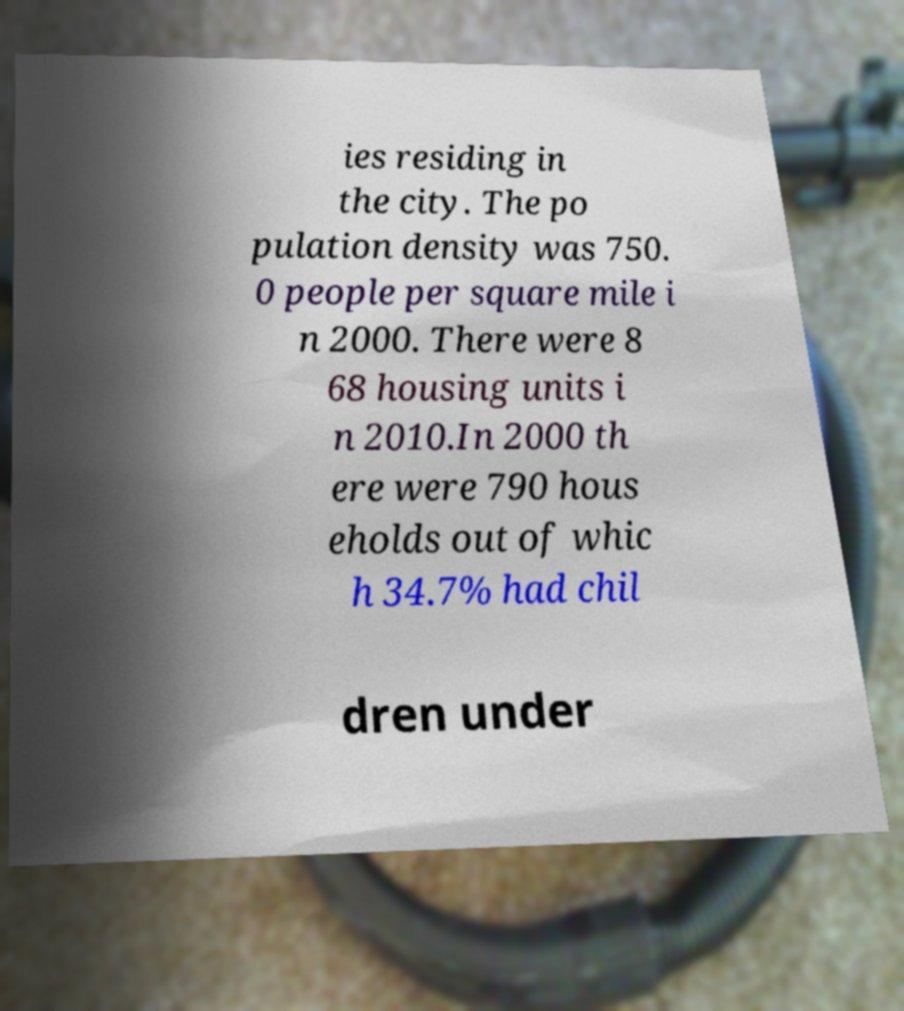Can you accurately transcribe the text from the provided image for me? ies residing in the city. The po pulation density was 750. 0 people per square mile i n 2000. There were 8 68 housing units i n 2010.In 2000 th ere were 790 hous eholds out of whic h 34.7% had chil dren under 